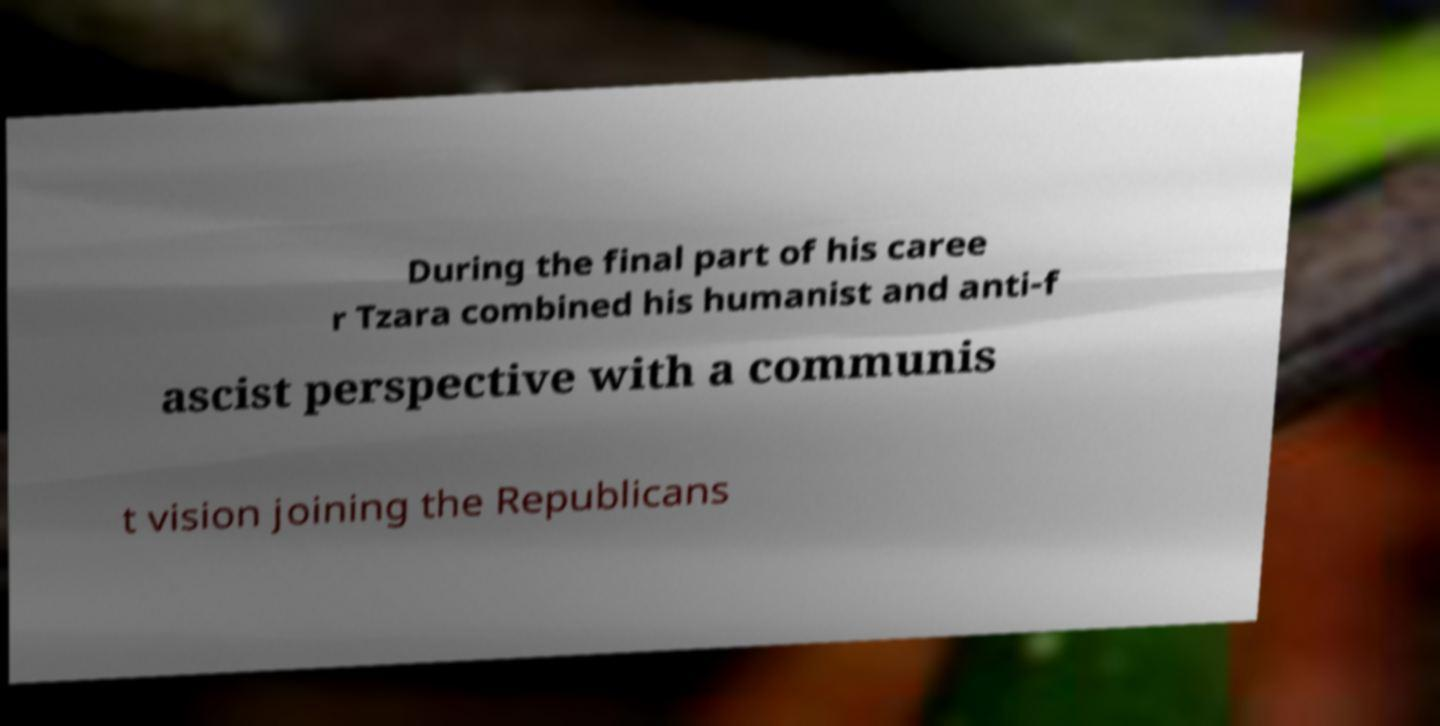Could you assist in decoding the text presented in this image and type it out clearly? During the final part of his caree r Tzara combined his humanist and anti-f ascist perspective with a communis t vision joining the Republicans 